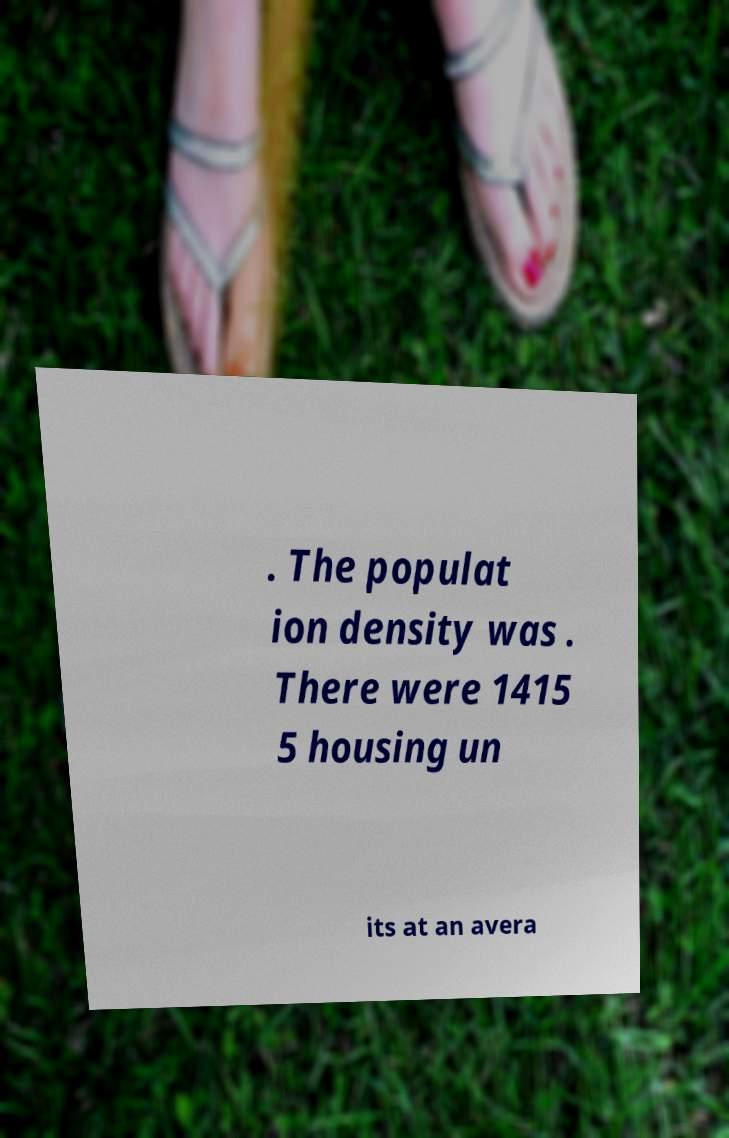Could you extract and type out the text from this image? . The populat ion density was . There were 1415 5 housing un its at an avera 